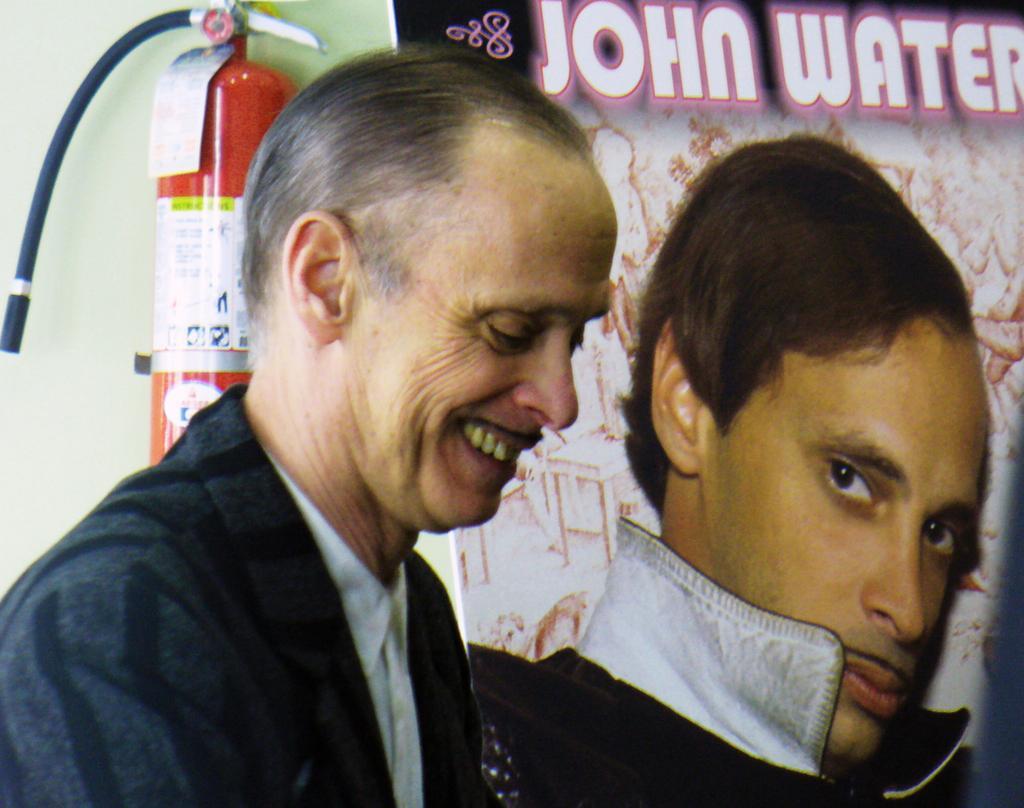Describe this image in one or two sentences. In this image there is a person smiling, and in the background there is a banner and an oxygen cylinder to the wall. 